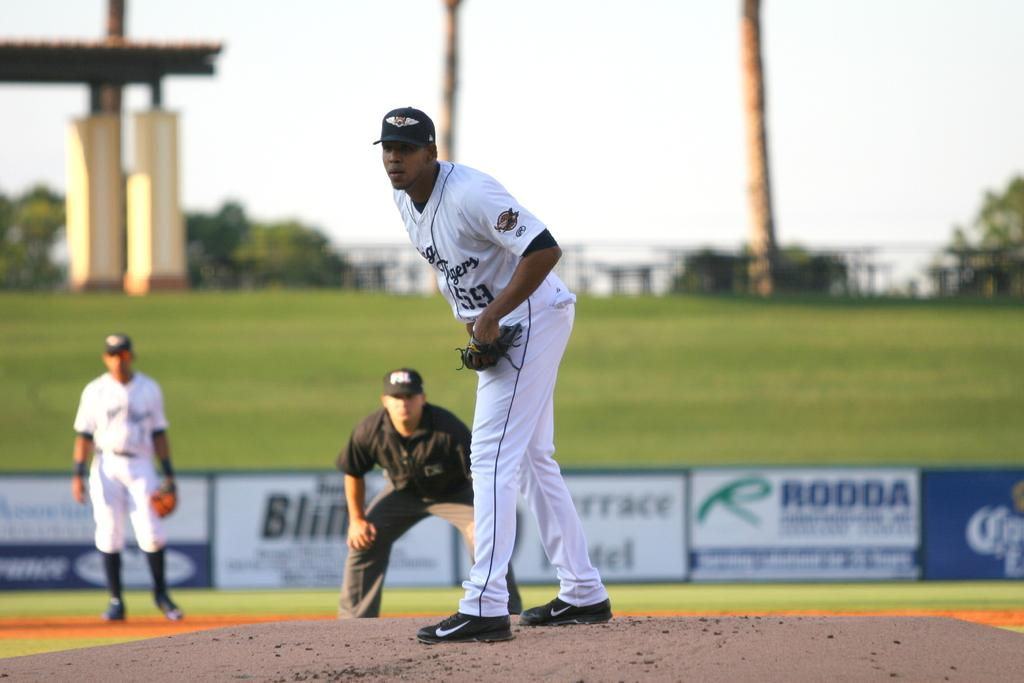<image>
Relay a brief, clear account of the picture shown. Two members of a baseball team and an umpire out on the field with advertisements such as Rodda in the background. 